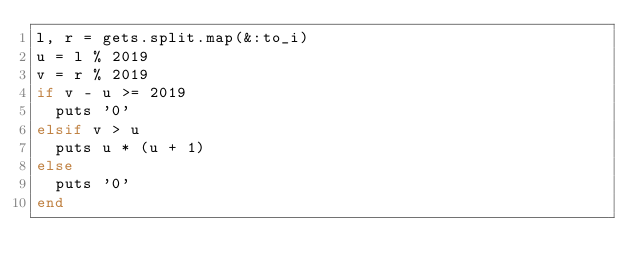Convert code to text. <code><loc_0><loc_0><loc_500><loc_500><_Ruby_>l, r = gets.split.map(&:to_i)
u = l % 2019
v = r % 2019
if v - u >= 2019
  puts '0'
elsif v > u
  puts u * (u + 1)
else
  puts '0'
end</code> 